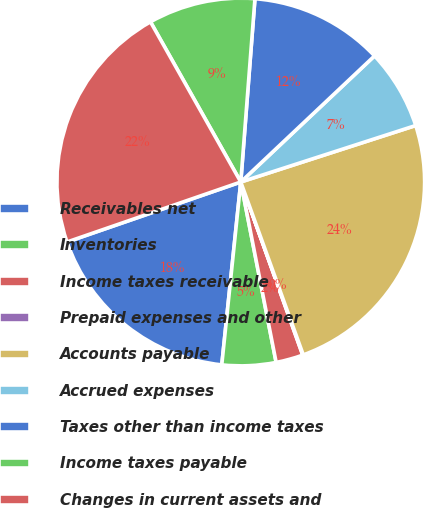Convert chart. <chart><loc_0><loc_0><loc_500><loc_500><pie_chart><fcel>Receivables net<fcel>Inventories<fcel>Income taxes receivable<fcel>Prepaid expenses and other<fcel>Accounts payable<fcel>Accrued expenses<fcel>Taxes other than income taxes<fcel>Income taxes payable<fcel>Changes in current assets and<nl><fcel>18.06%<fcel>4.73%<fcel>2.39%<fcel>0.05%<fcel>24.45%<fcel>7.06%<fcel>11.74%<fcel>9.4%<fcel>22.12%<nl></chart> 